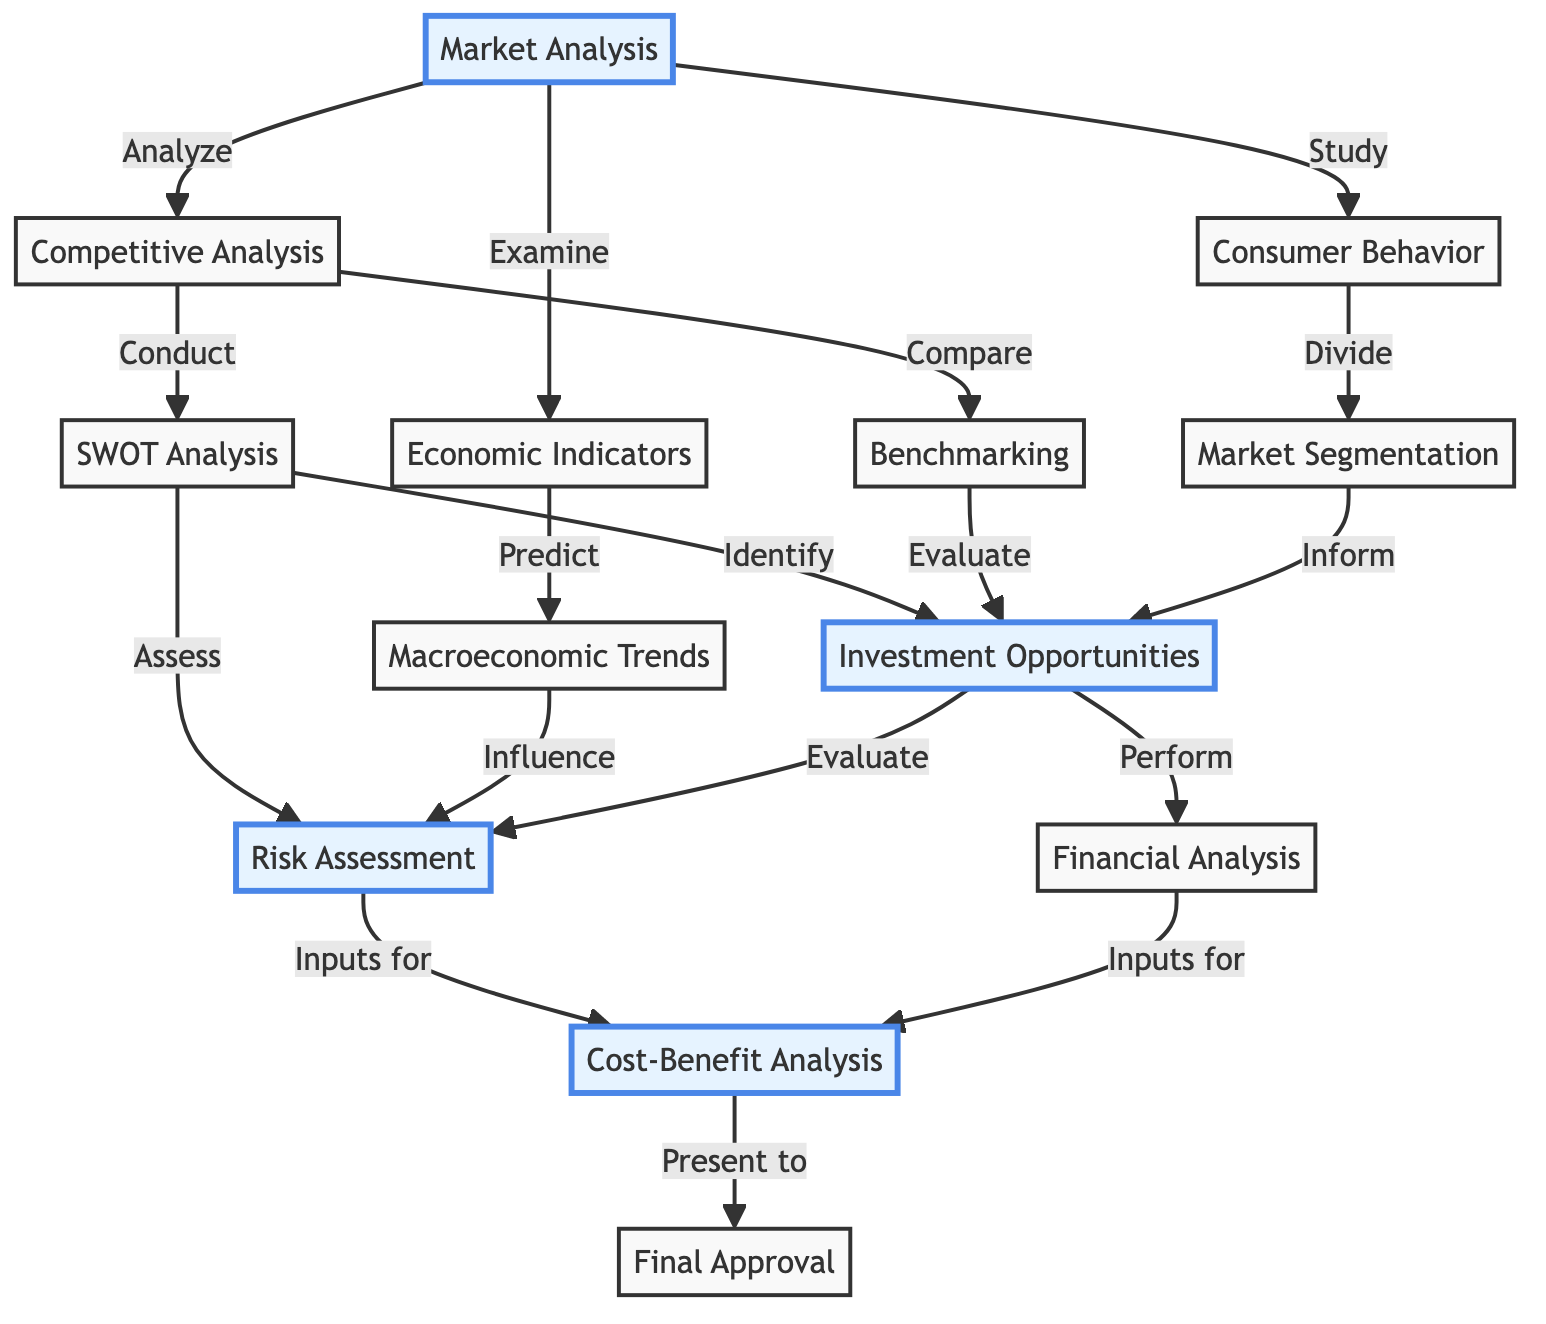What is the first step in the investment decision process? The diagram indicates that "Market Analysis" is the first step in the investment decision process, as it is the starting node with outgoing connections to multiple factors.
Answer: Market Analysis How many connections does "Investment Opportunities" have? The node for "Investment Opportunities" shows direct connections to "Risk Assessment" and "Financial Analysis," giving it a total of two connections.
Answer: 2 Which node follows "Risk Assessment"? The diagram shows that "Risk Assessment" leads directly to "Cost-Benefit Analysis," making it the subsequent node after "Risk Assessment."
Answer: Cost-Benefit Analysis What type of analysis is conducted directly after "SWOT Analysis"? The diagram reveals that "Risk Assessment" and "Investment Opportunities" follow "SWOT Analysis," indicating that both assessments are performed after it, making them direct analyses.
Answer: Risk Assessment, Investment Opportunities Which node involves examining key economic indicators? The node labeled "Economic Indicators" explicitly states that it involves examining key indicators like GDP, inflation, and employment levels, as represented in the diagram connections.
Answer: Economic Indicators What is the final step of the investment decision process? The diagram concludes with "Final Approval," which is the terminal node following the "Cost-Benefit Analysis."
Answer: Final Approval Which two nodes contribute inputs for the "Cost-Benefit Analysis"? The diagram specifies that both "Risk Assessment" and "Financial Analysis" provide inputs for the "Cost-Benefit Analysis," indicating their collaborative role in this step.
Answer: Risk Assessment, Financial Analysis How does "Consumer Behavior" relate to "Market Segmentation"? The diagram shows that "Consumer Behavior" connects to "Market Segmentation," indicating that understanding consumer patterns informs the segmentation of the larger market.
Answer: Study What follows "Macroeconomic Trends"? According to the diagram, the step that follows "Macroeconomic Trends" is "Risk Assessment," showing the direct connection and subsequent evaluation process.
Answer: Risk Assessment 